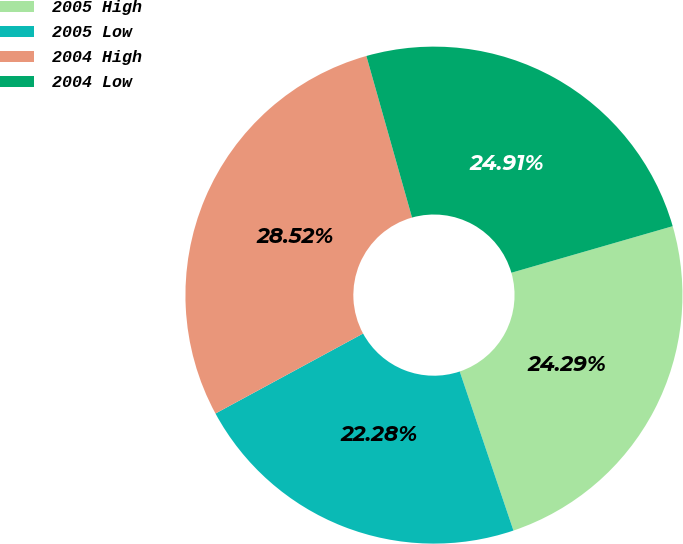Convert chart to OTSL. <chart><loc_0><loc_0><loc_500><loc_500><pie_chart><fcel>2005 High<fcel>2005 Low<fcel>2004 High<fcel>2004 Low<nl><fcel>24.29%<fcel>22.28%<fcel>28.52%<fcel>24.91%<nl></chart> 